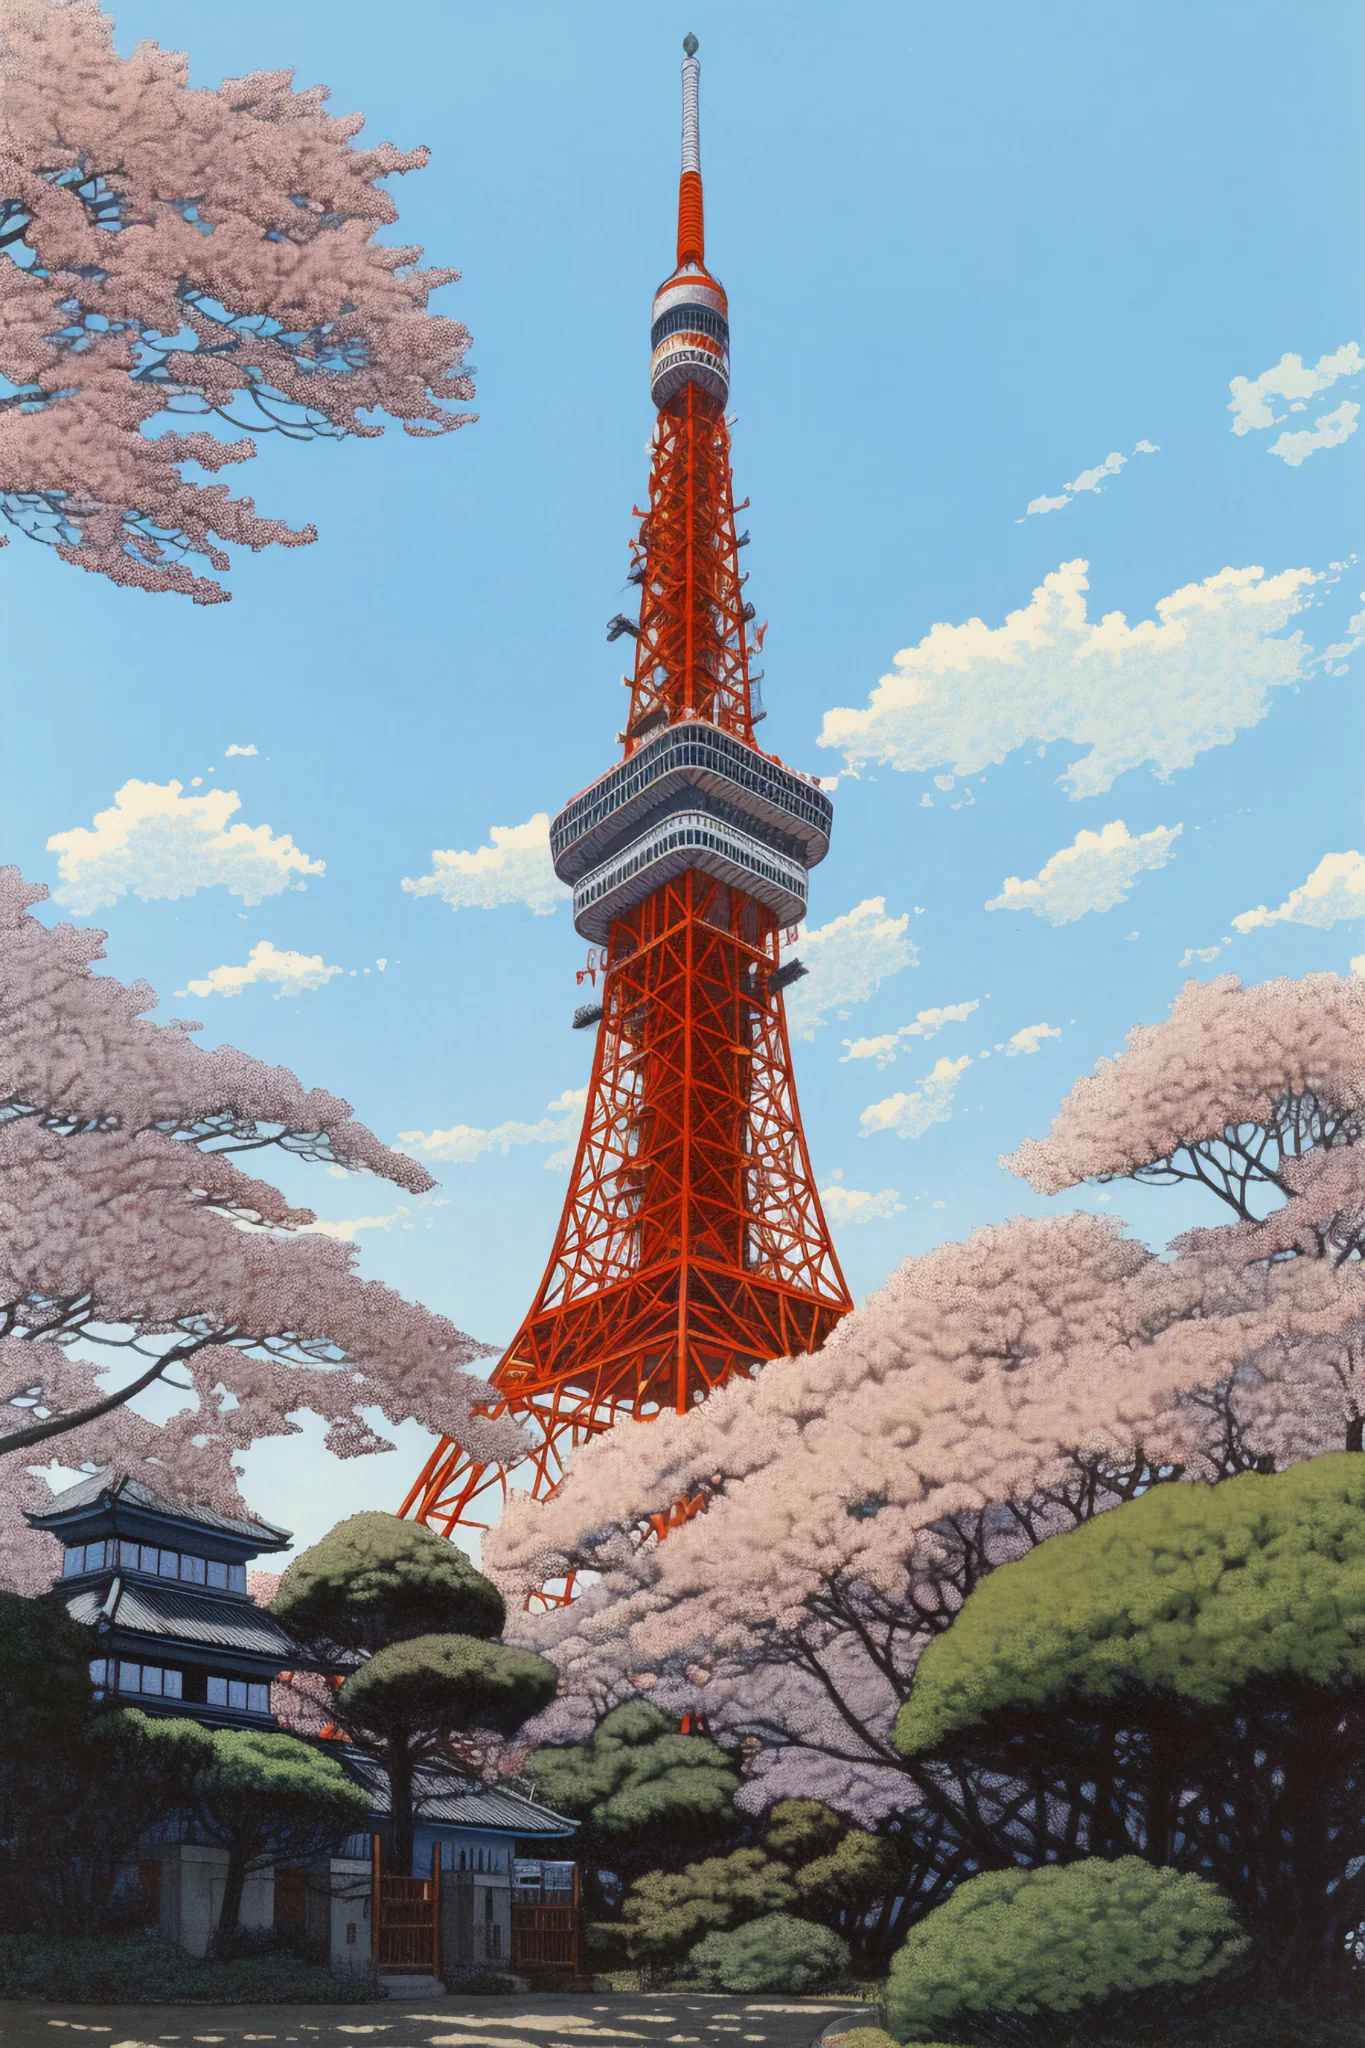Imagine this is a scene from a romantic movie. What might be happening here? In a romantic movie, this scene could depict a heartfelt confession under the Tokyo Tower during the cherry blossom festival. The lead characters, who have been dancing around their feelings for each other throughout the movie, find themselves alone under the sea of pink petals. As the sun sets and the tower lights up in the background, one character finally musters the courage to express their love, creating a beautiful and emotional climax to their story. The ambiance of the blossoms, the serene blue sky, and the towering landmark all contribute to a picturesque and unforgettable moment. How might the characters' outfits complement this romantic scene? The characters could be wearing traditional yet elegant attire that mirrors the serene and poetic nature of the setting. Perhaps the lead female character dons a delicate pink kimono with intricate cherry blossom embroidery, while the male character wears a tailored, modern yukata in subtle hues of blue and white. Their outfits would seamlessly blend with the soft colors of the blooming sakura, adding a touch of cultural authenticity and visual harmony to the romantic scene. 